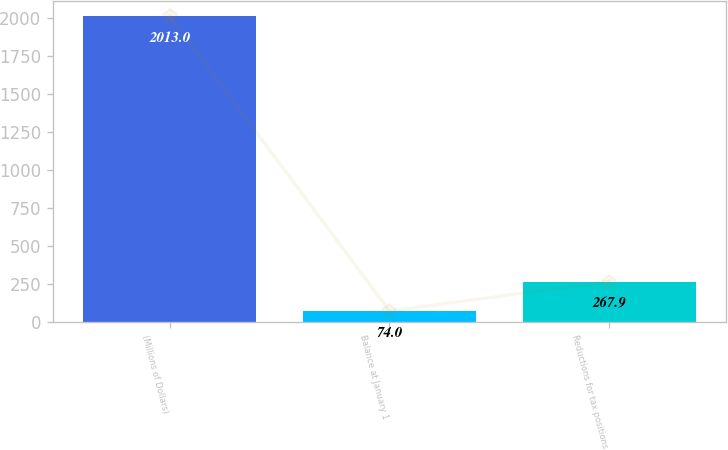Convert chart. <chart><loc_0><loc_0><loc_500><loc_500><bar_chart><fcel>(Millions of Dollars)<fcel>Balance at January 1<fcel>Reductions for tax positions<nl><fcel>2013<fcel>74<fcel>267.9<nl></chart> 